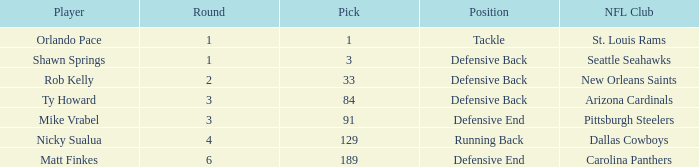What participant holds the defensive back position and has a round below 2? Shawn Springs. 